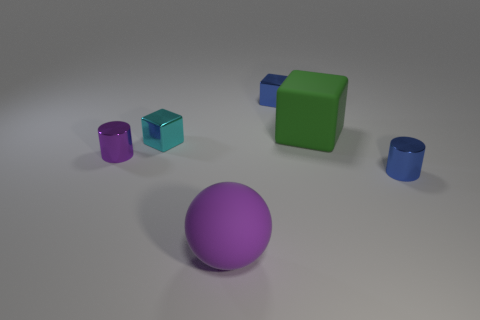Add 1 big green blocks. How many objects exist? 7 Subtract all spheres. How many objects are left? 5 Add 2 cyan cubes. How many cyan cubes exist? 3 Subtract 0 yellow cylinders. How many objects are left? 6 Subtract all large metal things. Subtract all small blue metal cylinders. How many objects are left? 5 Add 1 small metallic blocks. How many small metallic blocks are left? 3 